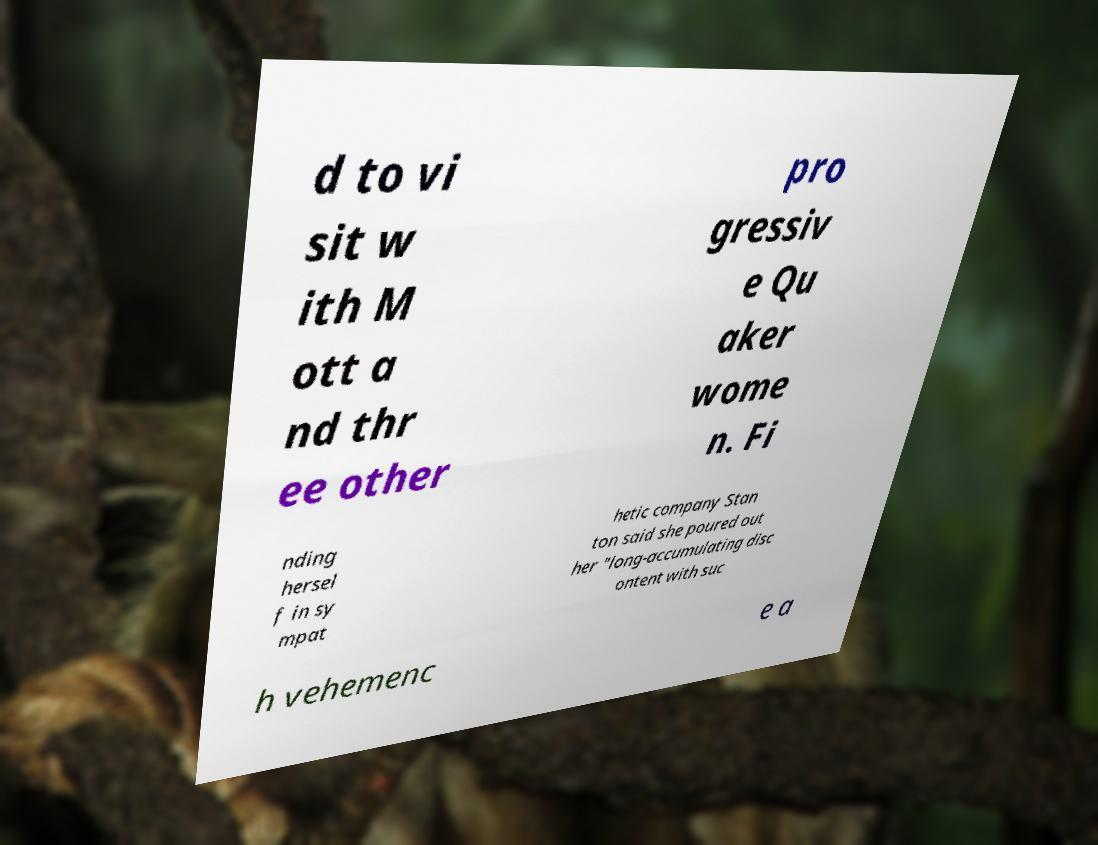Can you accurately transcribe the text from the provided image for me? d to vi sit w ith M ott a nd thr ee other pro gressiv e Qu aker wome n. Fi nding hersel f in sy mpat hetic company Stan ton said she poured out her "long-accumulating disc ontent with suc h vehemenc e a 